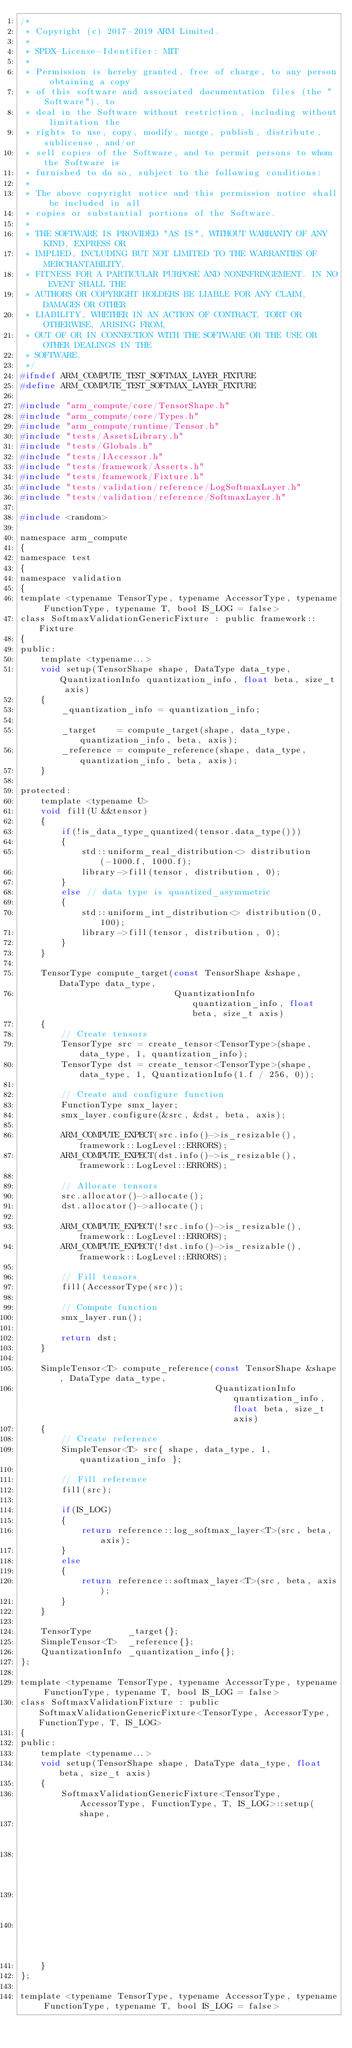Convert code to text. <code><loc_0><loc_0><loc_500><loc_500><_C_>/*
 * Copyright (c) 2017-2019 ARM Limited.
 *
 * SPDX-License-Identifier: MIT
 *
 * Permission is hereby granted, free of charge, to any person obtaining a copy
 * of this software and associated documentation files (the "Software"), to
 * deal in the Software without restriction, including without limitation the
 * rights to use, copy, modify, merge, publish, distribute, sublicense, and/or
 * sell copies of the Software, and to permit persons to whom the Software is
 * furnished to do so, subject to the following conditions:
 *
 * The above copyright notice and this permission notice shall be included in all
 * copies or substantial portions of the Software.
 *
 * THE SOFTWARE IS PROVIDED "AS IS", WITHOUT WARRANTY OF ANY KIND, EXPRESS OR
 * IMPLIED, INCLUDING BUT NOT LIMITED TO THE WARRANTIES OF MERCHANTABILITY,
 * FITNESS FOR A PARTICULAR PURPOSE AND NONINFRINGEMENT. IN NO EVENT SHALL THE
 * AUTHORS OR COPYRIGHT HOLDERS BE LIABLE FOR ANY CLAIM, DAMAGES OR OTHER
 * LIABILITY, WHETHER IN AN ACTION OF CONTRACT, TORT OR OTHERWISE, ARISING FROM,
 * OUT OF OR IN CONNECTION WITH THE SOFTWARE OR THE USE OR OTHER DEALINGS IN THE
 * SOFTWARE.
 */
#ifndef ARM_COMPUTE_TEST_SOFTMAX_LAYER_FIXTURE
#define ARM_COMPUTE_TEST_SOFTMAX_LAYER_FIXTURE

#include "arm_compute/core/TensorShape.h"
#include "arm_compute/core/Types.h"
#include "arm_compute/runtime/Tensor.h"
#include "tests/AssetsLibrary.h"
#include "tests/Globals.h"
#include "tests/IAccessor.h"
#include "tests/framework/Asserts.h"
#include "tests/framework/Fixture.h"
#include "tests/validation/reference/LogSoftmaxLayer.h"
#include "tests/validation/reference/SoftmaxLayer.h"

#include <random>

namespace arm_compute
{
namespace test
{
namespace validation
{
template <typename TensorType, typename AccessorType, typename FunctionType, typename T, bool IS_LOG = false>
class SoftmaxValidationGenericFixture : public framework::Fixture
{
public:
    template <typename...>
    void setup(TensorShape shape, DataType data_type, QuantizationInfo quantization_info, float beta, size_t axis)
    {
        _quantization_info = quantization_info;

        _target    = compute_target(shape, data_type, quantization_info, beta, axis);
        _reference = compute_reference(shape, data_type, quantization_info, beta, axis);
    }

protected:
    template <typename U>
    void fill(U &&tensor)
    {
        if(!is_data_type_quantized(tensor.data_type()))
        {
            std::uniform_real_distribution<> distribution(-1000.f, 1000.f);
            library->fill(tensor, distribution, 0);
        }
        else // data type is quantized_asymmetric
        {
            std::uniform_int_distribution<> distribution(0, 100);
            library->fill(tensor, distribution, 0);
        }
    }

    TensorType compute_target(const TensorShape &shape, DataType data_type,
                              QuantizationInfo quantization_info, float beta, size_t axis)
    {
        // Create tensors
        TensorType src = create_tensor<TensorType>(shape, data_type, 1, quantization_info);
        TensorType dst = create_tensor<TensorType>(shape, data_type, 1, QuantizationInfo(1.f / 256, 0));

        // Create and configure function
        FunctionType smx_layer;
        smx_layer.configure(&src, &dst, beta, axis);

        ARM_COMPUTE_EXPECT(src.info()->is_resizable(), framework::LogLevel::ERRORS);
        ARM_COMPUTE_EXPECT(dst.info()->is_resizable(), framework::LogLevel::ERRORS);

        // Allocate tensors
        src.allocator()->allocate();
        dst.allocator()->allocate();

        ARM_COMPUTE_EXPECT(!src.info()->is_resizable(), framework::LogLevel::ERRORS);
        ARM_COMPUTE_EXPECT(!dst.info()->is_resizable(), framework::LogLevel::ERRORS);

        // Fill tensors
        fill(AccessorType(src));

        // Compute function
        smx_layer.run();

        return dst;
    }

    SimpleTensor<T> compute_reference(const TensorShape &shape, DataType data_type,
                                      QuantizationInfo quantization_info, float beta, size_t axis)
    {
        // Create reference
        SimpleTensor<T> src{ shape, data_type, 1, quantization_info };

        // Fill reference
        fill(src);

        if(IS_LOG)
        {
            return reference::log_softmax_layer<T>(src, beta, axis);
        }
        else
        {
            return reference::softmax_layer<T>(src, beta, axis);
        }
    }

    TensorType       _target{};
    SimpleTensor<T>  _reference{};
    QuantizationInfo _quantization_info{};
};

template <typename TensorType, typename AccessorType, typename FunctionType, typename T, bool IS_LOG = false>
class SoftmaxValidationFixture : public SoftmaxValidationGenericFixture<TensorType, AccessorType, FunctionType, T, IS_LOG>
{
public:
    template <typename...>
    void setup(TensorShape shape, DataType data_type, float beta, size_t axis)
    {
        SoftmaxValidationGenericFixture<TensorType, AccessorType, FunctionType, T, IS_LOG>::setup(shape,
                                                                                                  data_type,
                                                                                                  QuantizationInfo(),
                                                                                                  beta,
                                                                                                  axis);
    }
};

template <typename TensorType, typename AccessorType, typename FunctionType, typename T, bool IS_LOG = false></code> 